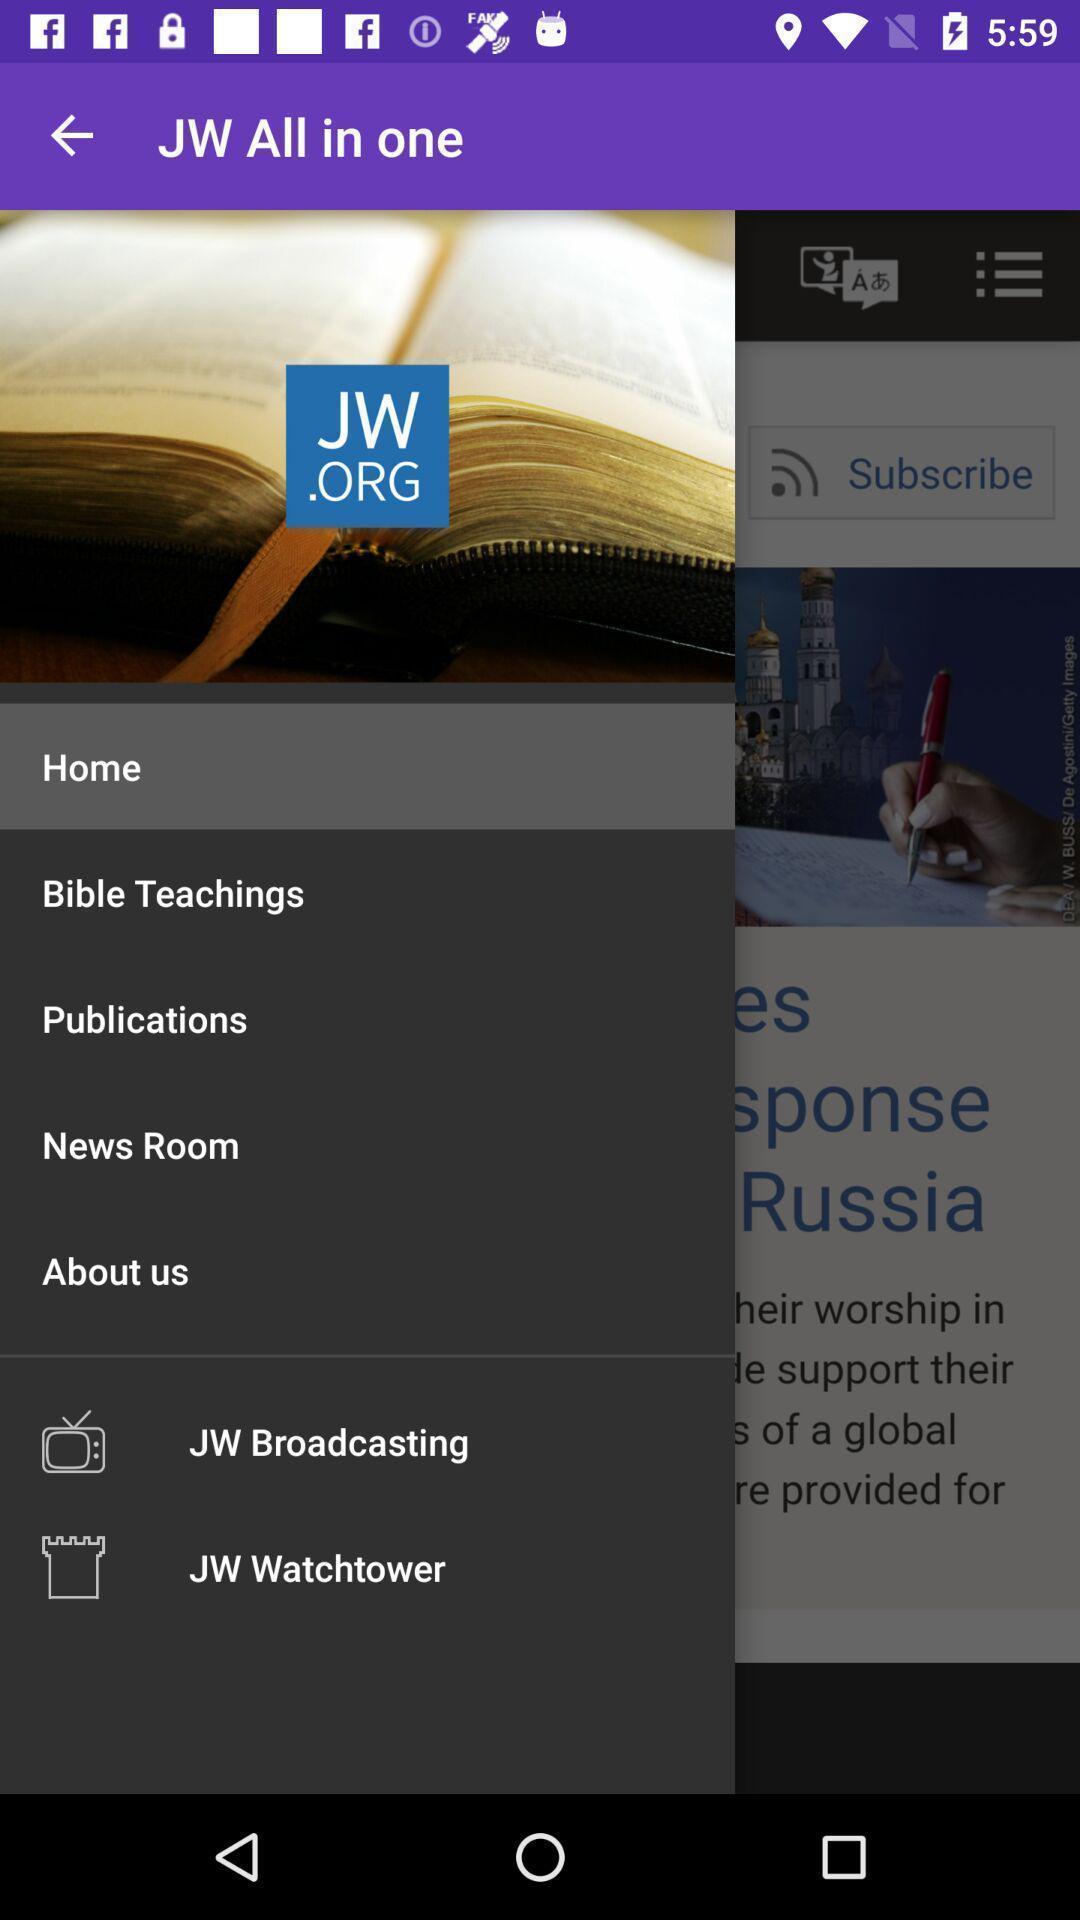What details can you identify in this image? Window displaying an bible app. 